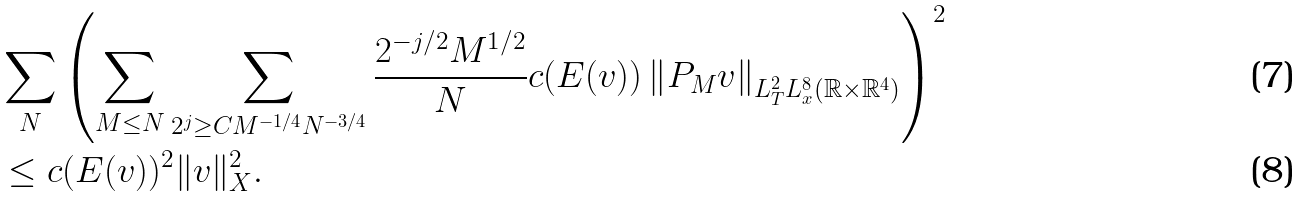Convert formula to latex. <formula><loc_0><loc_0><loc_500><loc_500>& \sum _ { N } \left ( \sum _ { M \leq N } \sum _ { 2 ^ { j } \geq C M ^ { - 1 / 4 } N ^ { - 3 / 4 } } \frac { 2 ^ { - j / 2 } M ^ { 1 / 2 } } { N } c ( E ( v ) ) \left \| P _ { M } v \right \| _ { L _ { T } ^ { 2 } L _ { x } ^ { 8 } ( \mathbb { R } \times \mathbb { R } ^ { 4 } ) } \right ) ^ { 2 } \\ & \leq c ( E ( v ) ) ^ { 2 } \| v \| _ { X } ^ { 2 } .</formula> 